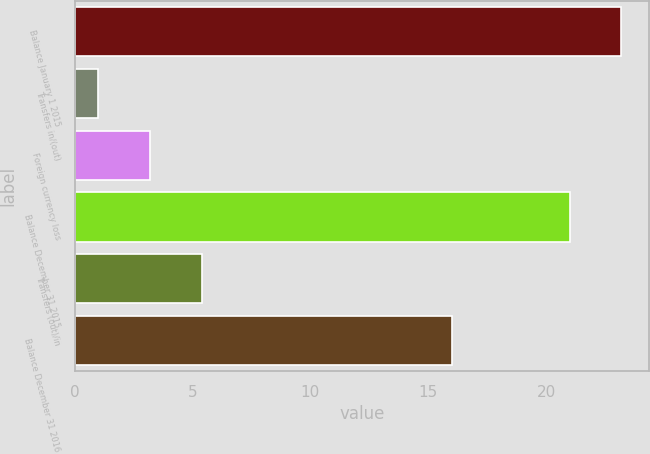<chart> <loc_0><loc_0><loc_500><loc_500><bar_chart><fcel>Balance January 1 2015<fcel>Transfers in/(out)<fcel>Foreign currency loss<fcel>Balance December 31 2015<fcel>Transfers (out)/in<fcel>Balance December 31 2016<nl><fcel>23.2<fcel>1<fcel>3.2<fcel>21<fcel>5.4<fcel>16<nl></chart> 